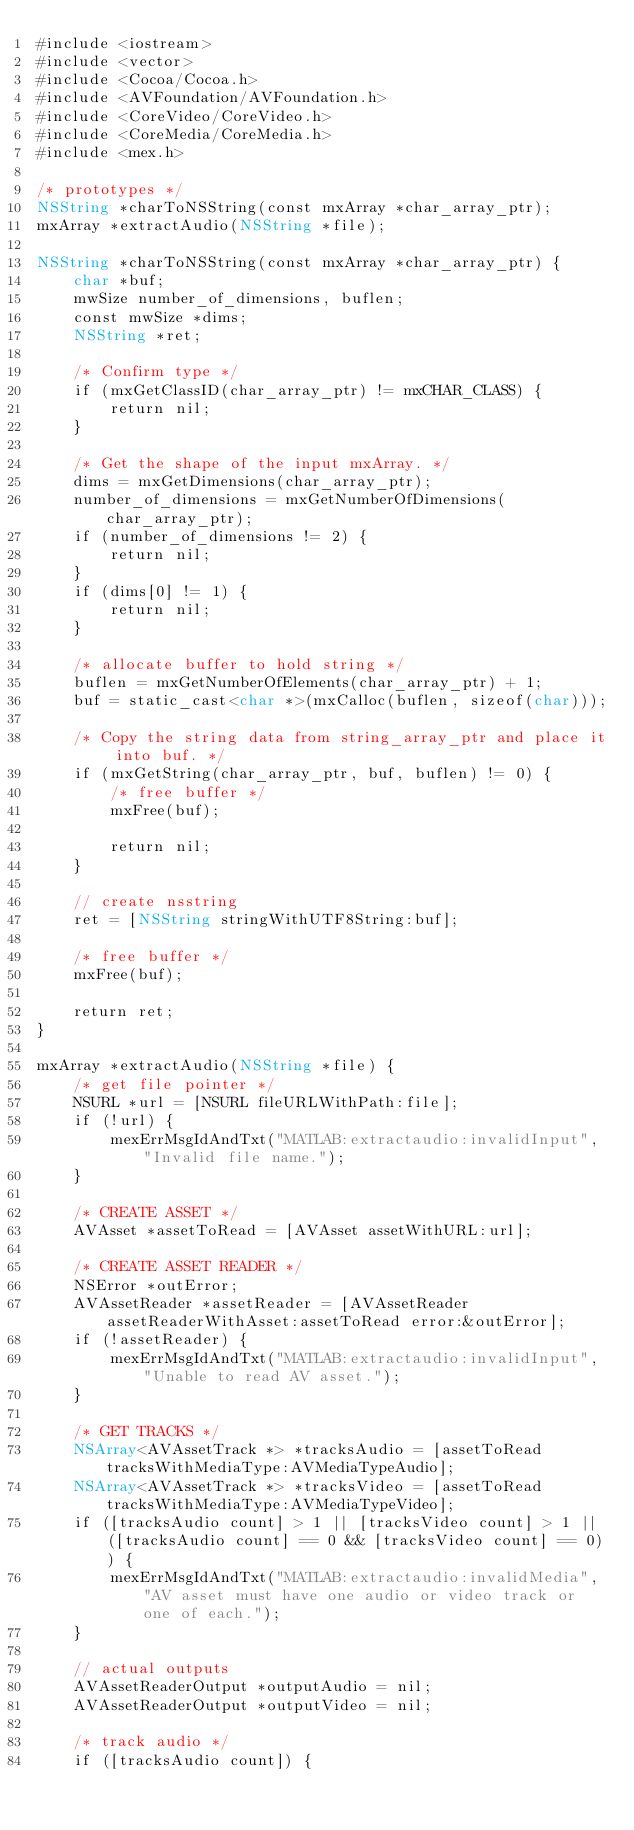Convert code to text. <code><loc_0><loc_0><loc_500><loc_500><_ObjectiveC_>#include <iostream>
#include <vector>
#include <Cocoa/Cocoa.h>
#include <AVFoundation/AVFoundation.h>
#include <CoreVideo/CoreVideo.h>
#include <CoreMedia/CoreMedia.h>
#include <mex.h>

/* prototypes */
NSString *charToNSString(const mxArray *char_array_ptr);
mxArray *extractAudio(NSString *file);

NSString *charToNSString(const mxArray *char_array_ptr) {
    char *buf;
    mwSize number_of_dimensions, buflen;
    const mwSize *dims;
    NSString *ret;
    
    /* Confirm type */
    if (mxGetClassID(char_array_ptr) != mxCHAR_CLASS) {
        return nil;
    }
    
    /* Get the shape of the input mxArray. */
    dims = mxGetDimensions(char_array_ptr);
    number_of_dimensions = mxGetNumberOfDimensions(char_array_ptr);
    if (number_of_dimensions != 2) {
        return nil;
    }
    if (dims[0] != 1) {
        return nil;
    }
    
    /* allocate buffer to hold string */
    buflen = mxGetNumberOfElements(char_array_ptr) + 1;
    buf = static_cast<char *>(mxCalloc(buflen, sizeof(char)));
    
    /* Copy the string data from string_array_ptr and place it into buf. */
    if (mxGetString(char_array_ptr, buf, buflen) != 0) {
        /* free buffer */
        mxFree(buf);
        
        return nil;
    }
    
    // create nsstring
    ret = [NSString stringWithUTF8String:buf];
    
    /* free buffer */
    mxFree(buf);
    
    return ret;
}

mxArray *extractAudio(NSString *file) {
    /* get file pointer */
    NSURL *url = [NSURL fileURLWithPath:file];
    if (!url) {
        mexErrMsgIdAndTxt("MATLAB:extractaudio:invalidInput", "Invalid file name.");
    }
    
    /* CREATE ASSET */
    AVAsset *assetToRead = [AVAsset assetWithURL:url];
    
    /* CREATE ASSET READER */
    NSError *outError;
    AVAssetReader *assetReader = [AVAssetReader assetReaderWithAsset:assetToRead error:&outError];
    if (!assetReader) {
        mexErrMsgIdAndTxt("MATLAB:extractaudio:invalidInput", "Unable to read AV asset.");
    }
    
    /* GET TRACKS */
    NSArray<AVAssetTrack *> *tracksAudio = [assetToRead tracksWithMediaType:AVMediaTypeAudio];
    NSArray<AVAssetTrack *> *tracksVideo = [assetToRead tracksWithMediaType:AVMediaTypeVideo];
    if ([tracksAudio count] > 1 || [tracksVideo count] > 1 || ([tracksAudio count] == 0 && [tracksVideo count] == 0)) {
        mexErrMsgIdAndTxt("MATLAB:extractaudio:invalidMedia", "AV asset must have one audio or video track or one of each.");
    }
    
    // actual outputs
    AVAssetReaderOutput *outputAudio = nil;
    AVAssetReaderOutput *outputVideo = nil;
    
    /* track audio */
    if ([tracksAudio count]) {</code> 